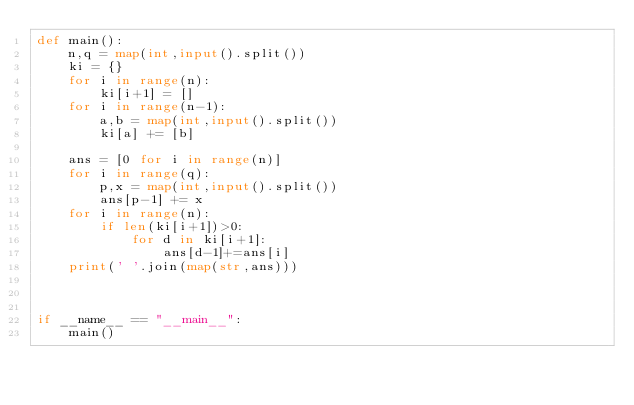<code> <loc_0><loc_0><loc_500><loc_500><_Python_>def main():
    n,q = map(int,input().split())
    ki = {}
    for i in range(n):
        ki[i+1] = []
    for i in range(n-1):
        a,b = map(int,input().split())
        ki[a] += [b]

    ans = [0 for i in range(n)]
    for i in range(q):
        p,x = map(int,input().split())
        ans[p-1] += x
    for i in range(n):
        if len(ki[i+1])>0:
            for d in ki[i+1]:
                ans[d-1]+=ans[i]
    print(' '.join(map(str,ans)))
        


if __name__ == "__main__":
    main()</code> 